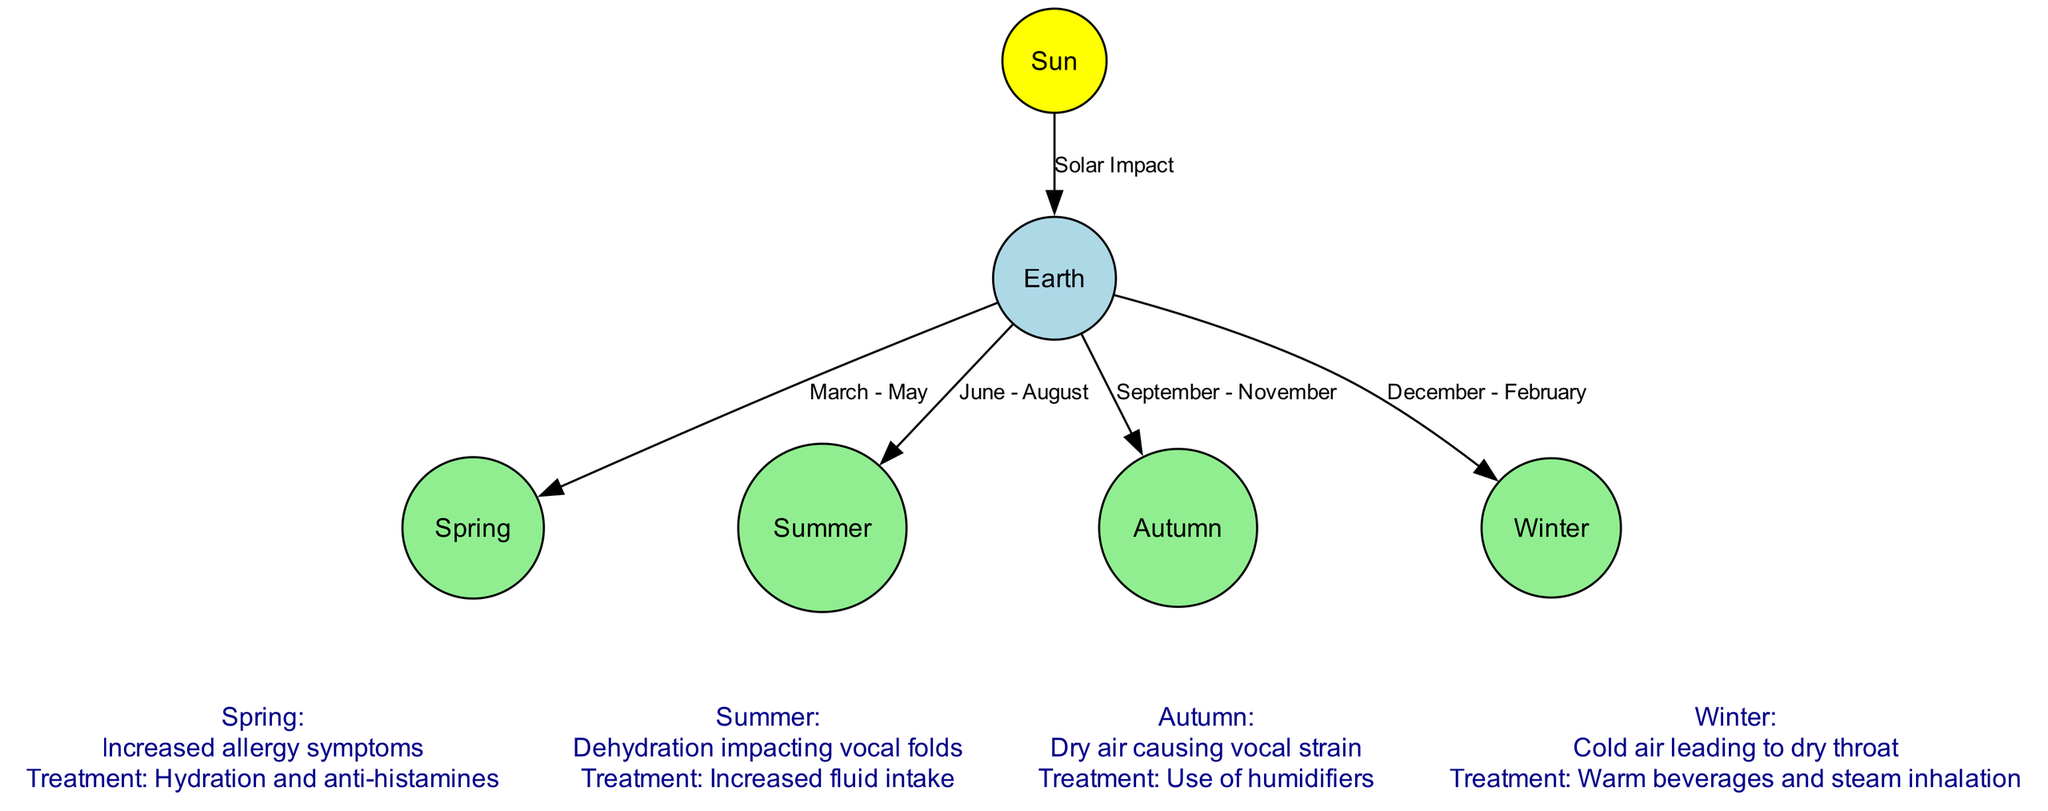What is the central star in the diagram? The diagram identifies the "Sun" as the central star, which influences the seasonal variations that affect vocal health. This is clearly labeled as a node in the diagram.
Answer: Sun How many seasons are represented in the diagram? The diagram includes four distinct seasonal nodes: Spring, Summer, Autumn, and Winter. Counting these nodes gives the total number of seasons represented.
Answer: Four What label connects the Earth to Spring? The diagram shows an edge connecting "Earth" to "Spring" with the label "March - May." This label indicates the time period associated with the Spring season.
Answer: March - May Which season is associated with dehydration impacting vocal folds? The additional information in the diagram states that "Summer" is the season associated with dehydration impacting vocal folds. It gives treatment recommendations specific to this symptom.
Answer: Summer What treatment is suggested for cold air leading to a dry throat in Winter? The diagram specifies that the treatment for the symptom related to Winter, which is cold air leading to a dry throat, is "Warm beverages and steam inhalation." This detail is connected to the Winter node.
Answer: Warm beverages and steam inhalation What season corresponds with increased allergy symptoms? Referring to the additional information provided for Spring, it states that the season corresponds with "Increased allergy symptoms." This links the symptom directly to the Spring node.
Answer: Spring How does the Earth's position in relation to the Sun relate to seasonal changes? The diagram establishes a direct connection through an edge labeled "Solar Impact," indicating that the position of Earth in relation to the Sun influences seasonal changes that affect vocal health. Therefore, the relationship is fundamental to understanding these variations.
Answer: Solar Impact Which season's symptom is dry air causing vocal strain? The diagram shows that Autumn is associated with the symptom of "Dry air causing vocal strain," which is indicated in the additional information section related to the Autumn node.
Answer: Autumn 